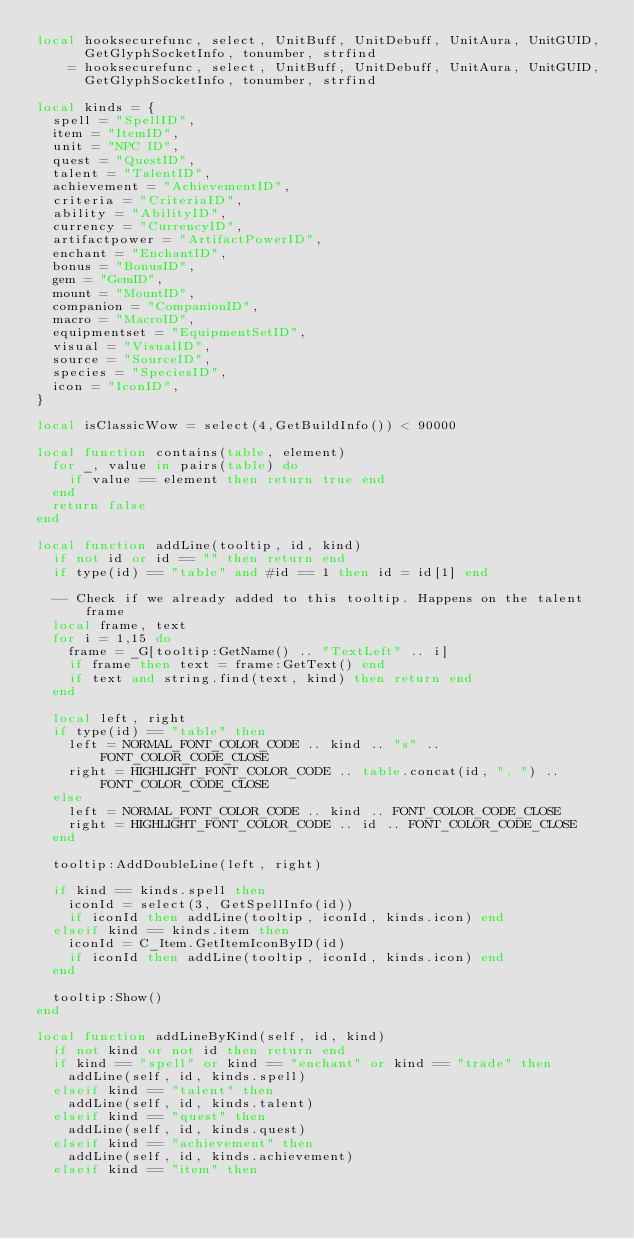Convert code to text. <code><loc_0><loc_0><loc_500><loc_500><_Lua_>local hooksecurefunc, select, UnitBuff, UnitDebuff, UnitAura, UnitGUID,
      GetGlyphSocketInfo, tonumber, strfind
    = hooksecurefunc, select, UnitBuff, UnitDebuff, UnitAura, UnitGUID,
      GetGlyphSocketInfo, tonumber, strfind

local kinds = {
  spell = "SpellID",
  item = "ItemID",
  unit = "NPC ID",
  quest = "QuestID",
  talent = "TalentID",
  achievement = "AchievementID",
  criteria = "CriteriaID",
  ability = "AbilityID",
  currency = "CurrencyID",
  artifactpower = "ArtifactPowerID",
  enchant = "EnchantID",
  bonus = "BonusID",
  gem = "GemID",
  mount = "MountID",
  companion = "CompanionID",
  macro = "MacroID",
  equipmentset = "EquipmentSetID",
  visual = "VisualID",
  source = "SourceID",
  species = "SpeciesID",
  icon = "IconID",
}

local isClassicWow = select(4,GetBuildInfo()) < 90000

local function contains(table, element)
  for _, value in pairs(table) do
    if value == element then return true end
  end
  return false
end

local function addLine(tooltip, id, kind)
  if not id or id == "" then return end
  if type(id) == "table" and #id == 1 then id = id[1] end

  -- Check if we already added to this tooltip. Happens on the talent frame
  local frame, text
  for i = 1,15 do
    frame = _G[tooltip:GetName() .. "TextLeft" .. i]
    if frame then text = frame:GetText() end
    if text and string.find(text, kind) then return end
  end

  local left, right
  if type(id) == "table" then
    left = NORMAL_FONT_COLOR_CODE .. kind .. "s" .. FONT_COLOR_CODE_CLOSE
    right = HIGHLIGHT_FONT_COLOR_CODE .. table.concat(id, ", ") .. FONT_COLOR_CODE_CLOSE
  else
    left = NORMAL_FONT_COLOR_CODE .. kind .. FONT_COLOR_CODE_CLOSE
    right = HIGHLIGHT_FONT_COLOR_CODE .. id .. FONT_COLOR_CODE_CLOSE
  end

  tooltip:AddDoubleLine(left, right)

  if kind == kinds.spell then
    iconId = select(3, GetSpellInfo(id))
    if iconId then addLine(tooltip, iconId, kinds.icon) end
  elseif kind == kinds.item then
    iconId = C_Item.GetItemIconByID(id)
    if iconId then addLine(tooltip, iconId, kinds.icon) end
  end

  tooltip:Show()
end

local function addLineByKind(self, id, kind)
  if not kind or not id then return end
  if kind == "spell" or kind == "enchant" or kind == "trade" then
    addLine(self, id, kinds.spell)
  elseif kind == "talent" then
    addLine(self, id, kinds.talent)
  elseif kind == "quest" then
    addLine(self, id, kinds.quest)
  elseif kind == "achievement" then
    addLine(self, id, kinds.achievement)
  elseif kind == "item" then</code> 